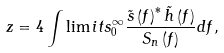Convert formula to latex. <formula><loc_0><loc_0><loc_500><loc_500>z = 4 \int \lim i t s _ { 0 } ^ { \infty } { \frac { \tilde { s } \left ( { f } \right ) ^ { \ast } \tilde { h } \left ( { f } \right ) } { S _ { n } \left ( { f } \right ) } } d f ,</formula> 